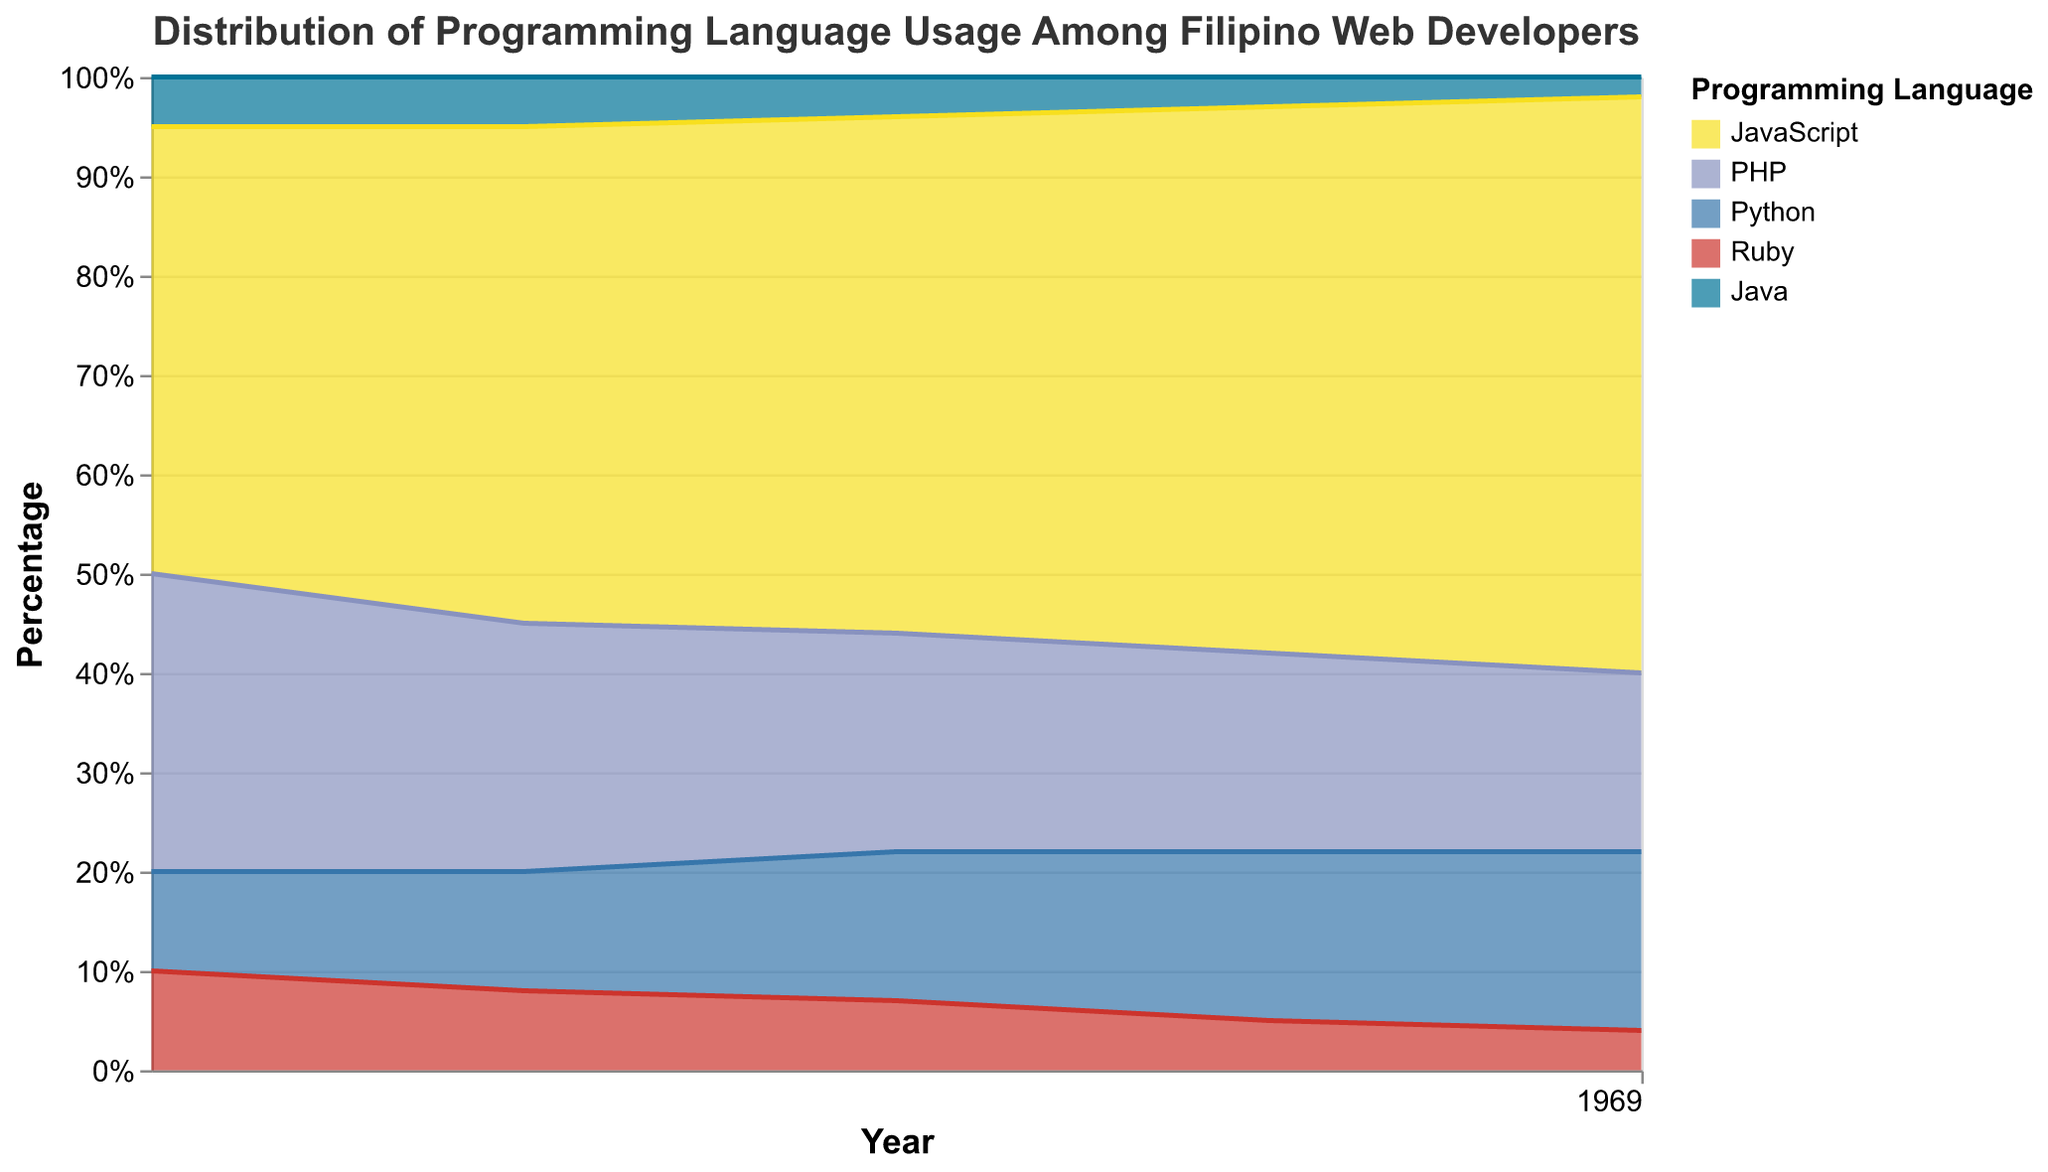What is the title of the chart? The title of the chart is located at the top, showing the subject of the visualization.
Answer: Distribution of Programming Language Usage Among Filipino Web Developers Which programming language had the highest percentage of usage in 2022? By visually inspecting the stacked areas for 2022, JavaScript's area is the largest.
Answer: JavaScript How did the percentage of PHP usage change from 2018 to 2022? By comparing the height of the PHP segment in 2018 and 2022, the segment decreases over time.
Answer: Decreased Which year shows the highest percentage of JavaScript usage? Identify the year with the largest area allocated for JavaScript by moving along the x-axis.
Answer: 2022 What is the trend of Python usage from 2018 to 2022? Observe the change in the area of Python from 2018 to 2022. The area increases year by year.
Answer: Increasing How did Ruby's usage change from 2018 to 2022? Compare the Ruby segment over the years, which decreases in size.
Answer: Decreased In which year did JavaScript overtake PHP in usage percentage? Observe where the JavaScript area surpassed PHP's area visually on the chart.
Answer: 2019 Which languages show a continuous increase in usage percentage every year from 2018 to 2022? Ascertain the areas that increment steadily throughout the timeline.
Answer: JavaScript, Python What is the percentage difference in usage between Python and Java in 2020? Locate and subtract the segment values for Python and Java in 2020 on the chart.
Answer: 11% Did any language completely drop off from the chart by 2022? Check the segments for a noticeable absence in 2022.
Answer: No Which programming language showed the least fluctuation in usage percentage from 2018 to 2022? Compare the relative shapes of areas and their consistency across years.
Answer: Java 